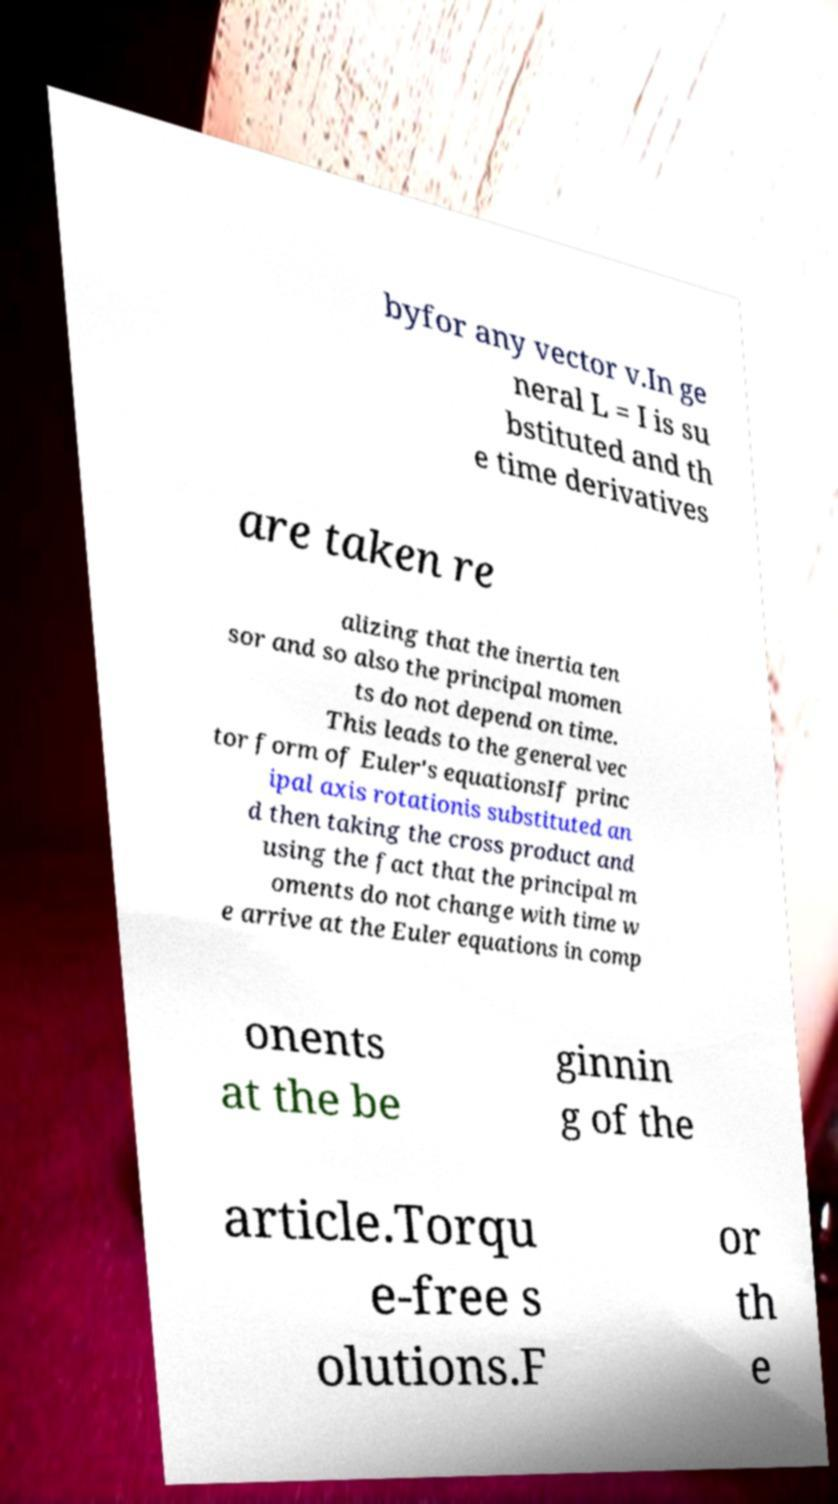Can you accurately transcribe the text from the provided image for me? byfor any vector v.In ge neral L = I is su bstituted and th e time derivatives are taken re alizing that the inertia ten sor and so also the principal momen ts do not depend on time. This leads to the general vec tor form of Euler's equationsIf princ ipal axis rotationis substituted an d then taking the cross product and using the fact that the principal m oments do not change with time w e arrive at the Euler equations in comp onents at the be ginnin g of the article.Torqu e-free s olutions.F or th e 